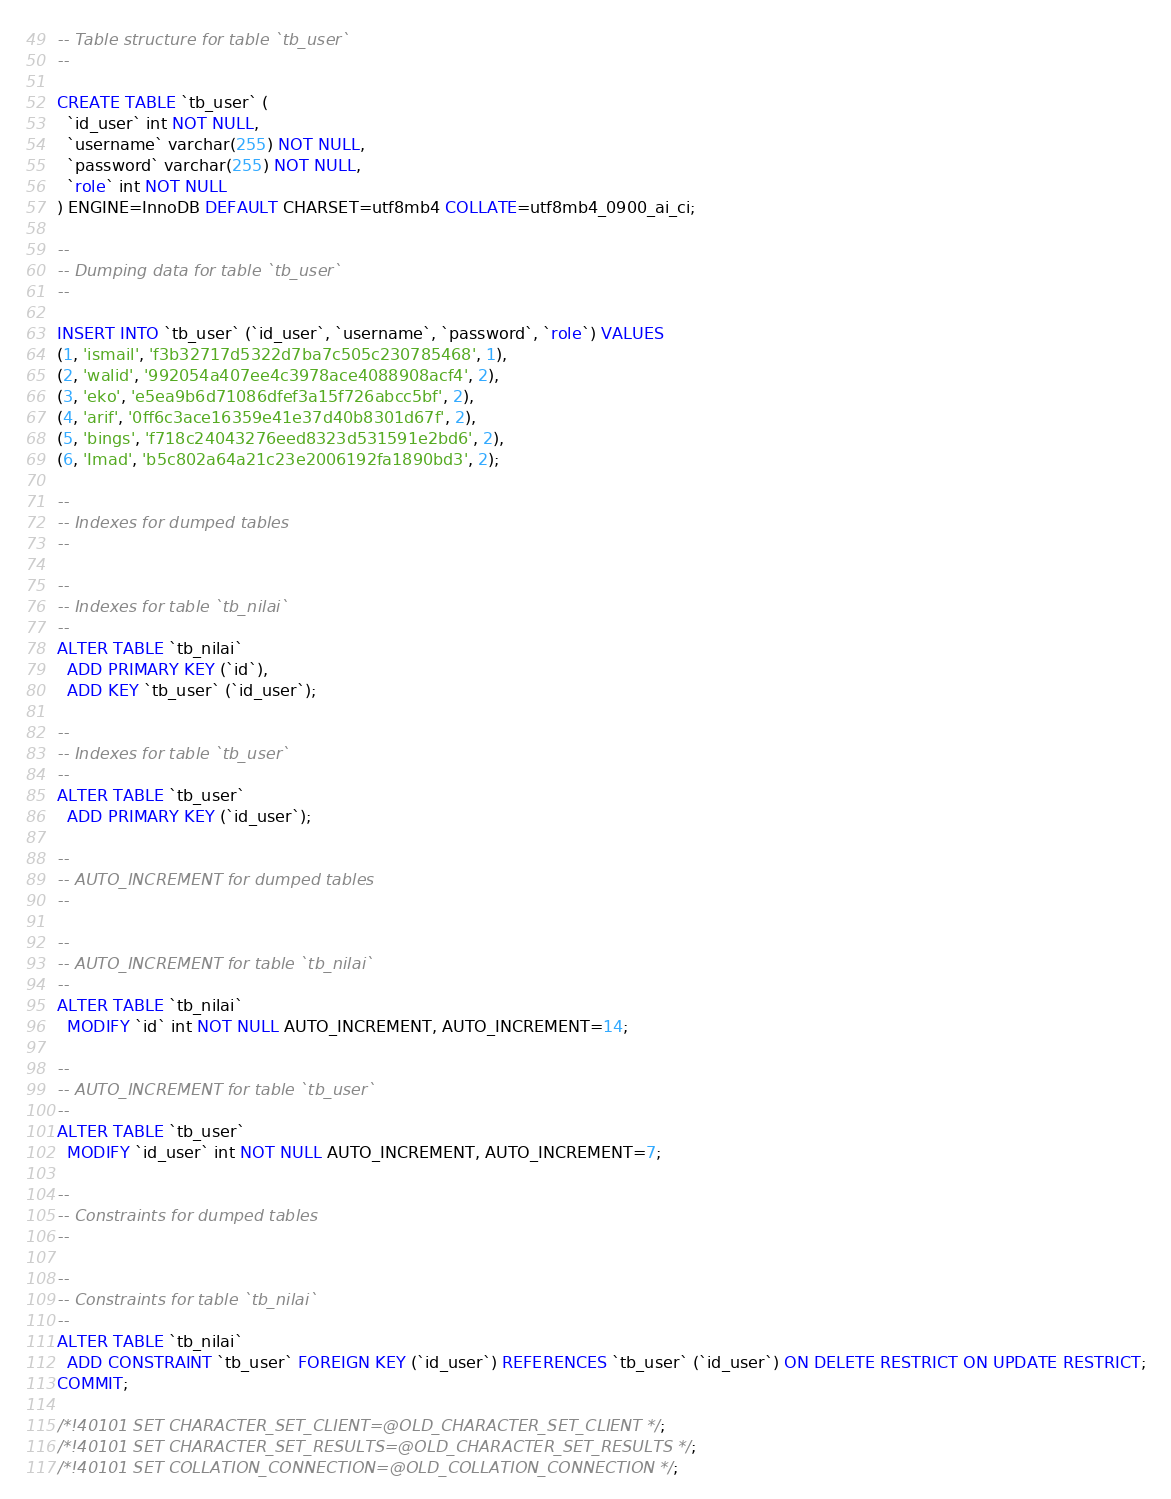<code> <loc_0><loc_0><loc_500><loc_500><_SQL_>-- Table structure for table `tb_user`
--

CREATE TABLE `tb_user` (
  `id_user` int NOT NULL,
  `username` varchar(255) NOT NULL,
  `password` varchar(255) NOT NULL,
  `role` int NOT NULL
) ENGINE=InnoDB DEFAULT CHARSET=utf8mb4 COLLATE=utf8mb4_0900_ai_ci;

--
-- Dumping data for table `tb_user`
--

INSERT INTO `tb_user` (`id_user`, `username`, `password`, `role`) VALUES
(1, 'ismail', 'f3b32717d5322d7ba7c505c230785468', 1),
(2, 'walid', '992054a407ee4c3978ace4088908acf4', 2),
(3, 'eko', 'e5ea9b6d71086dfef3a15f726abcc5bf', 2),
(4, 'arif', '0ff6c3ace16359e41e37d40b8301d67f', 2),
(5, 'bings', 'f718c24043276eed8323d531591e2bd6', 2),
(6, 'Imad', 'b5c802a64a21c23e2006192fa1890bd3', 2);

--
-- Indexes for dumped tables
--

--
-- Indexes for table `tb_nilai`
--
ALTER TABLE `tb_nilai`
  ADD PRIMARY KEY (`id`),
  ADD KEY `tb_user` (`id_user`);

--
-- Indexes for table `tb_user`
--
ALTER TABLE `tb_user`
  ADD PRIMARY KEY (`id_user`);

--
-- AUTO_INCREMENT for dumped tables
--

--
-- AUTO_INCREMENT for table `tb_nilai`
--
ALTER TABLE `tb_nilai`
  MODIFY `id` int NOT NULL AUTO_INCREMENT, AUTO_INCREMENT=14;

--
-- AUTO_INCREMENT for table `tb_user`
--
ALTER TABLE `tb_user`
  MODIFY `id_user` int NOT NULL AUTO_INCREMENT, AUTO_INCREMENT=7;

--
-- Constraints for dumped tables
--

--
-- Constraints for table `tb_nilai`
--
ALTER TABLE `tb_nilai`
  ADD CONSTRAINT `tb_user` FOREIGN KEY (`id_user`) REFERENCES `tb_user` (`id_user`) ON DELETE RESTRICT ON UPDATE RESTRICT;
COMMIT;

/*!40101 SET CHARACTER_SET_CLIENT=@OLD_CHARACTER_SET_CLIENT */;
/*!40101 SET CHARACTER_SET_RESULTS=@OLD_CHARACTER_SET_RESULTS */;
/*!40101 SET COLLATION_CONNECTION=@OLD_COLLATION_CONNECTION */;
</code> 